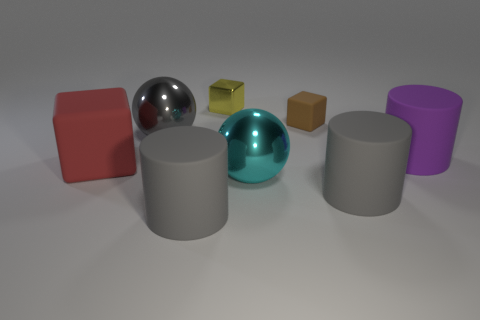What shape is the cyan metal object that is the same size as the gray ball?
Your answer should be very brief. Sphere. How many objects are either red rubber cubes or metal spheres?
Your answer should be very brief. 3. Are there any shiny things?
Provide a succinct answer. Yes. Are there fewer big matte cubes than objects?
Provide a short and direct response. Yes. Are there any brown metallic cubes of the same size as the gray ball?
Make the answer very short. No. There is a brown rubber thing; does it have the same shape as the gray object that is behind the cyan object?
Your answer should be very brief. No. How many cubes are either large purple matte things or shiny things?
Offer a terse response. 1. The tiny rubber cube has what color?
Your response must be concise. Brown. Are there more big cyan shiny spheres than blue metallic cylinders?
Keep it short and to the point. Yes. How many things are either big gray objects right of the tiny matte cube or gray matte cylinders?
Your answer should be compact. 2. 